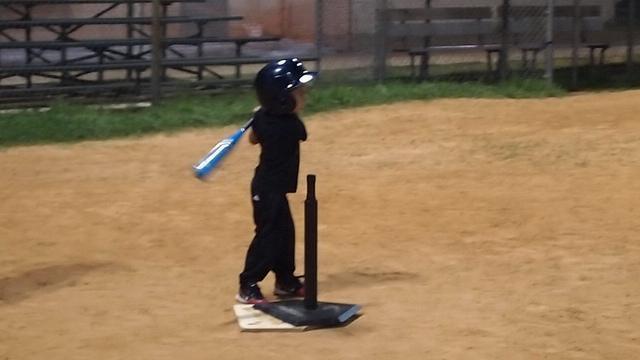How many benches can you see?
Give a very brief answer. 4. 